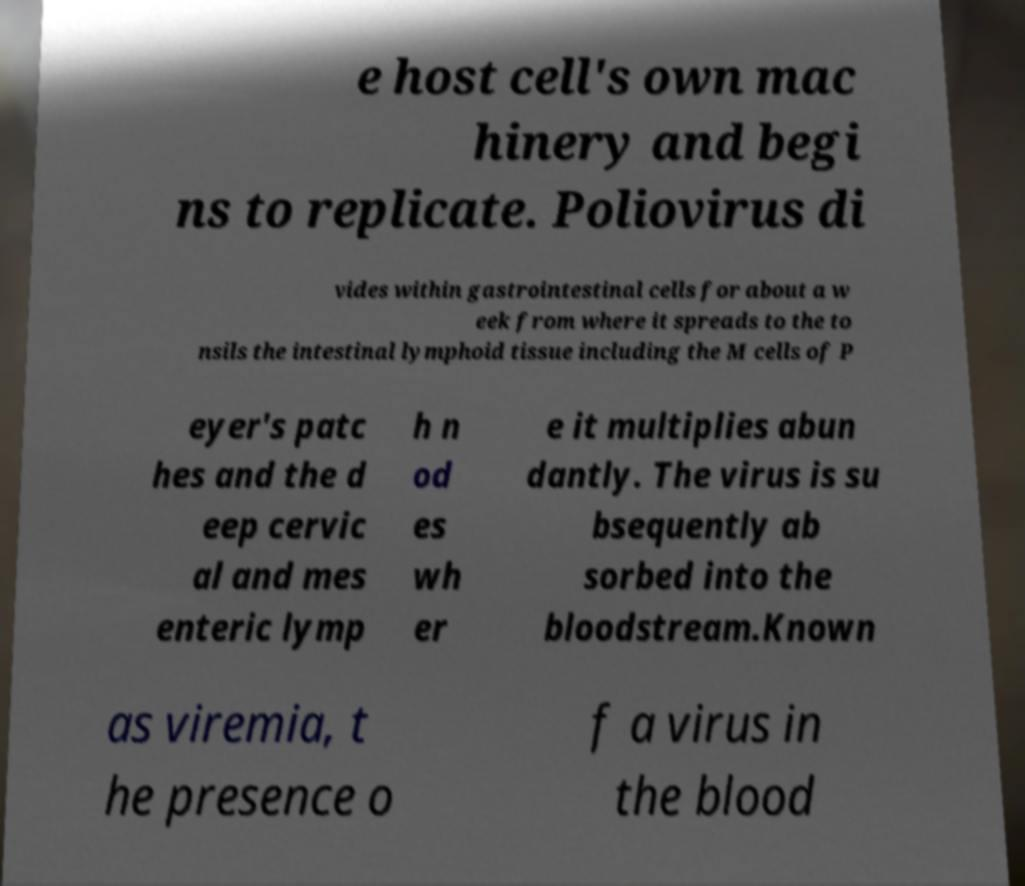Can you read and provide the text displayed in the image?This photo seems to have some interesting text. Can you extract and type it out for me? e host cell's own mac hinery and begi ns to replicate. Poliovirus di vides within gastrointestinal cells for about a w eek from where it spreads to the to nsils the intestinal lymphoid tissue including the M cells of P eyer's patc hes and the d eep cervic al and mes enteric lymp h n od es wh er e it multiplies abun dantly. The virus is su bsequently ab sorbed into the bloodstream.Known as viremia, t he presence o f a virus in the blood 